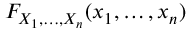Convert formula to latex. <formula><loc_0><loc_0><loc_500><loc_500>F _ { X _ { 1 } , \dots , X _ { n } } ( x _ { 1 } , \dots , x _ { n } )</formula> 